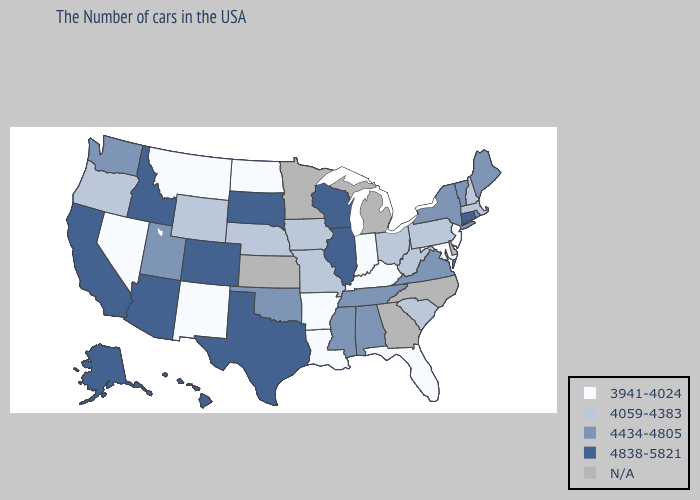Is the legend a continuous bar?
Be succinct. No. Name the states that have a value in the range 4838-5821?
Quick response, please. Connecticut, Wisconsin, Illinois, Texas, South Dakota, Colorado, Arizona, Idaho, California, Alaska, Hawaii. Which states have the lowest value in the West?
Concise answer only. New Mexico, Montana, Nevada. Does New York have the lowest value in the USA?
Give a very brief answer. No. Does Arizona have the lowest value in the USA?
Concise answer only. No. Name the states that have a value in the range N/A?
Write a very short answer. Delaware, North Carolina, Georgia, Michigan, Minnesota, Kansas. What is the value of Wisconsin?
Keep it brief. 4838-5821. What is the highest value in the MidWest ?
Short answer required. 4838-5821. Which states have the highest value in the USA?
Keep it brief. Connecticut, Wisconsin, Illinois, Texas, South Dakota, Colorado, Arizona, Idaho, California, Alaska, Hawaii. What is the value of Missouri?
Write a very short answer. 4059-4383. Name the states that have a value in the range 3941-4024?
Keep it brief. New Jersey, Maryland, Florida, Kentucky, Indiana, Louisiana, Arkansas, North Dakota, New Mexico, Montana, Nevada. What is the value of Michigan?
Concise answer only. N/A. Does the map have missing data?
Quick response, please. Yes. Name the states that have a value in the range 4434-4805?
Keep it brief. Maine, Rhode Island, Vermont, New York, Virginia, Alabama, Tennessee, Mississippi, Oklahoma, Utah, Washington. 